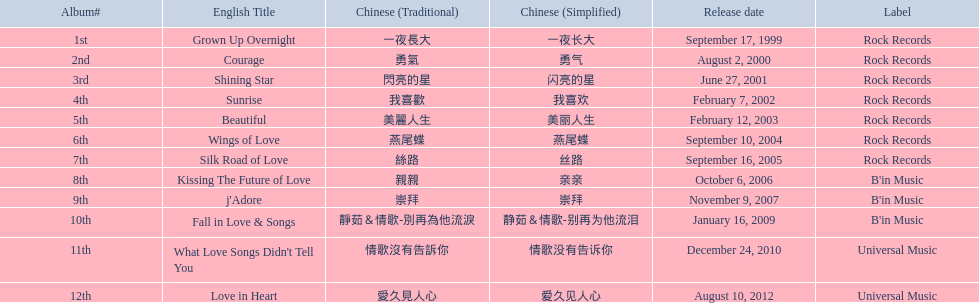Which english titles were published during even years? Courage, Sunrise, Silk Road of Love, Kissing The Future of Love, What Love Songs Didn't Tell You, Love in Heart. From the provided choices, which one can be found in the "b's" category of music? Kissing The Future of Love. 